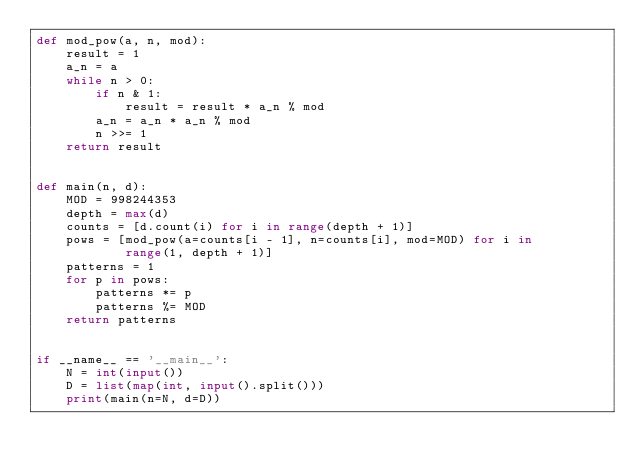Convert code to text. <code><loc_0><loc_0><loc_500><loc_500><_Python_>def mod_pow(a, n, mod):
    result = 1
    a_n = a
    while n > 0:
        if n & 1:
            result = result * a_n % mod
        a_n = a_n * a_n % mod
        n >>= 1
    return result


def main(n, d):
    MOD = 998244353
    depth = max(d)
    counts = [d.count(i) for i in range(depth + 1)]
    pows = [mod_pow(a=counts[i - 1], n=counts[i], mod=MOD) for i in
            range(1, depth + 1)]
    patterns = 1
    for p in pows:
        patterns *= p
        patterns %= MOD
    return patterns


if __name__ == '__main__':
    N = int(input())
    D = list(map(int, input().split()))
    print(main(n=N, d=D))
</code> 